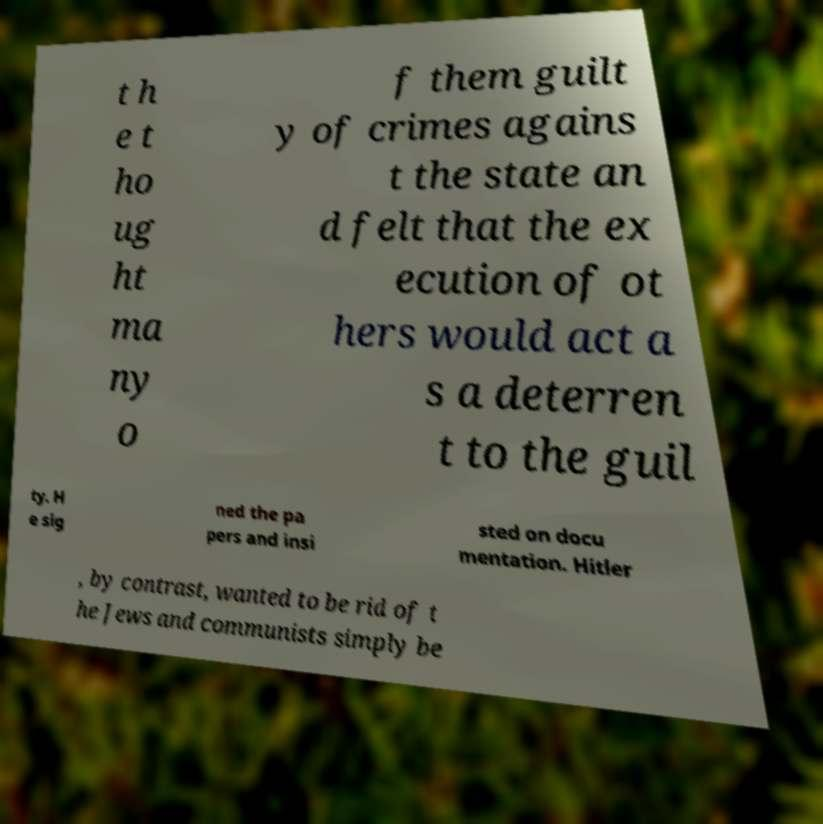Could you extract and type out the text from this image? t h e t ho ug ht ma ny o f them guilt y of crimes agains t the state an d felt that the ex ecution of ot hers would act a s a deterren t to the guil ty. H e sig ned the pa pers and insi sted on docu mentation. Hitler , by contrast, wanted to be rid of t he Jews and communists simply be 